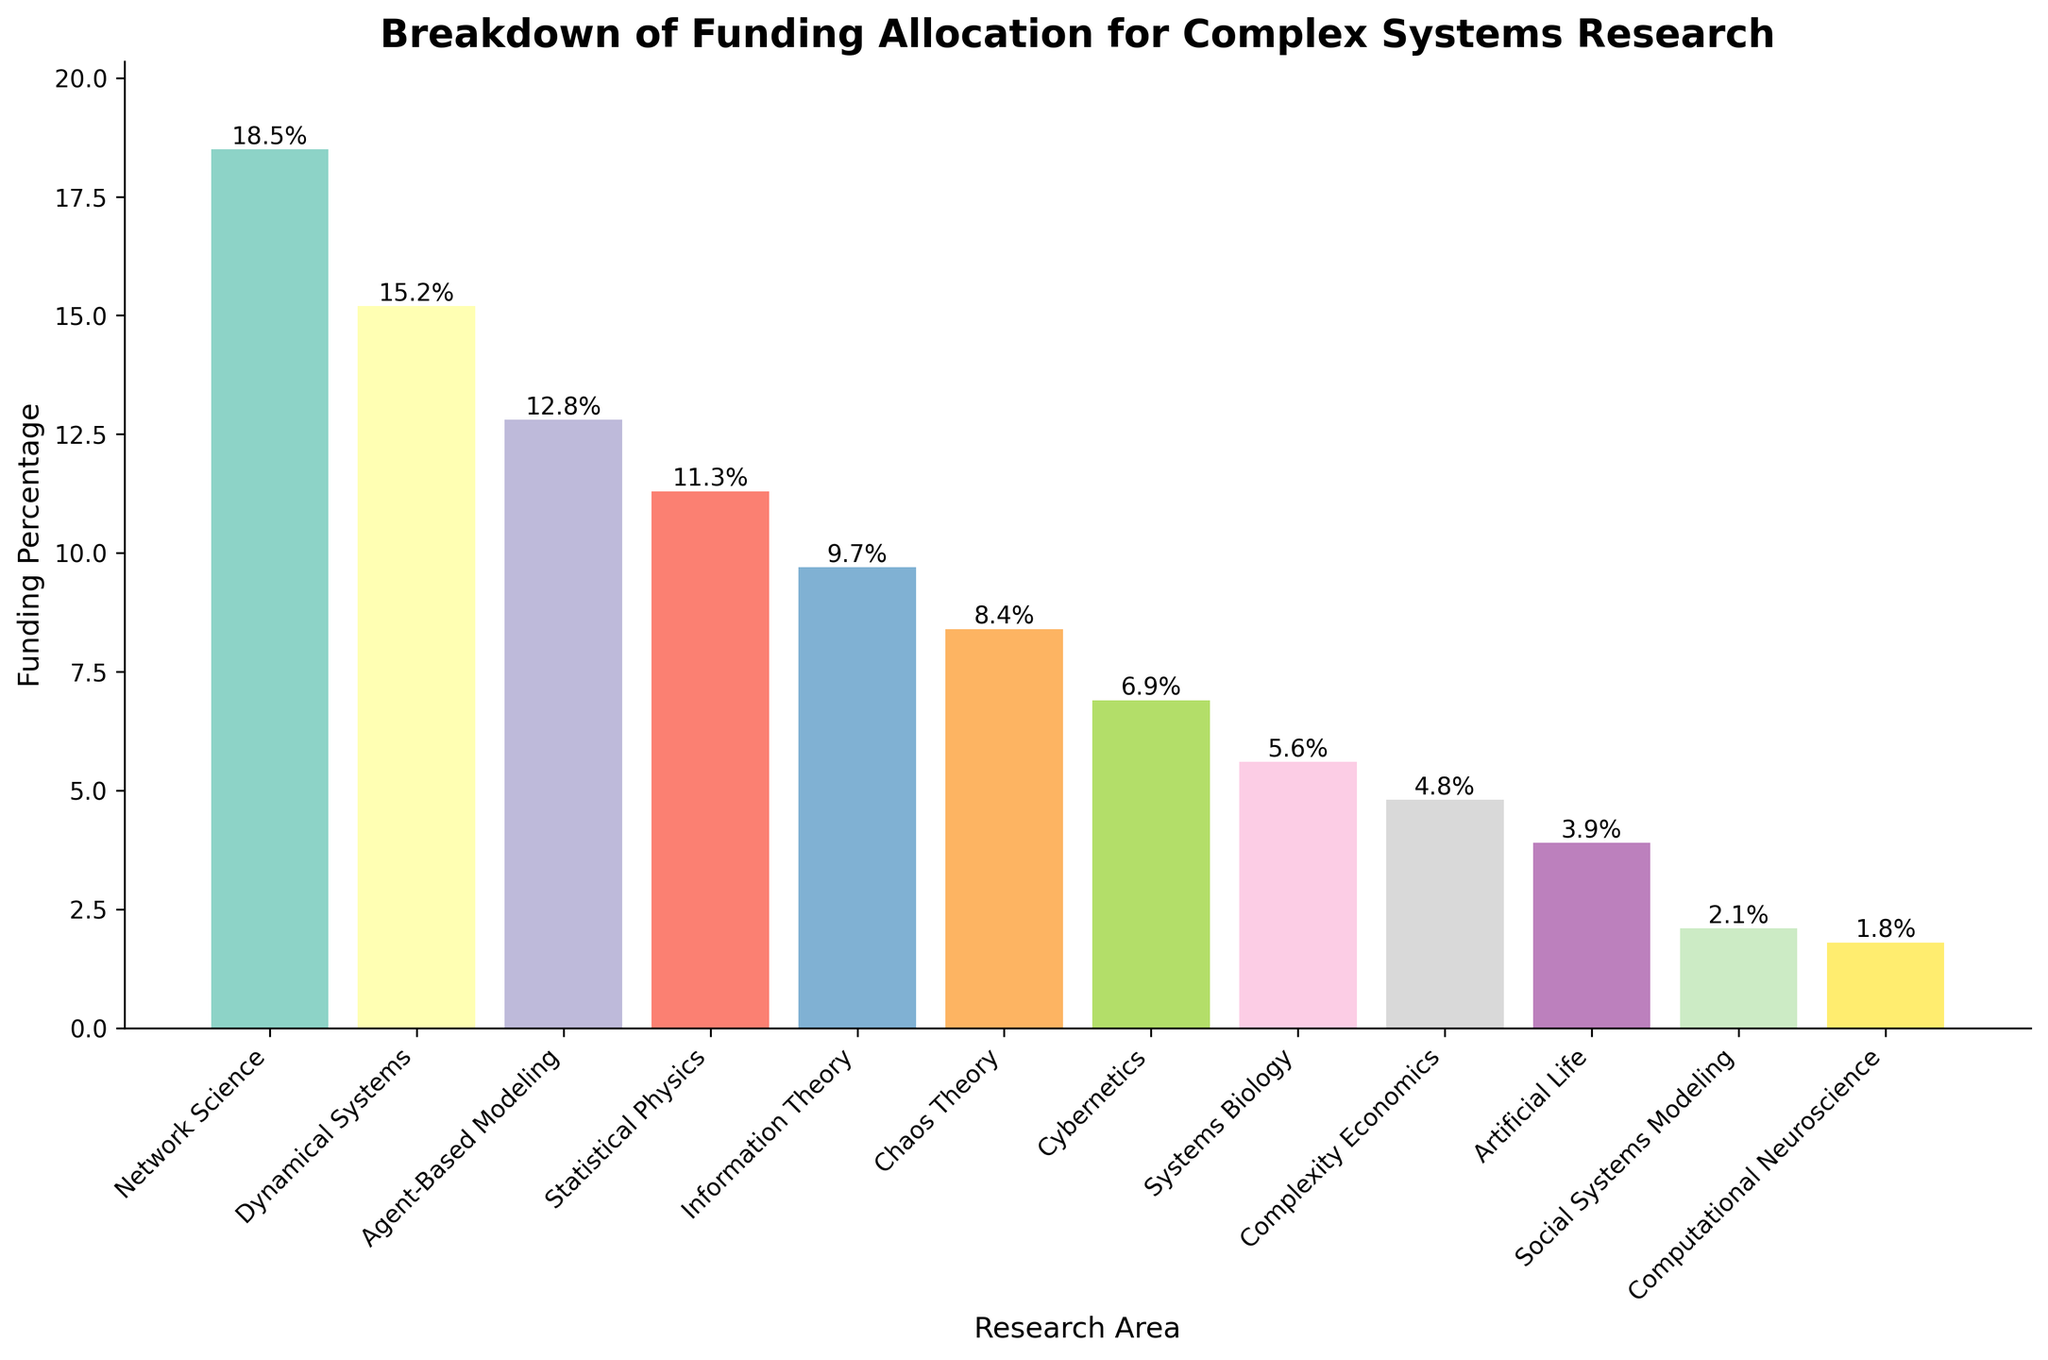What's the highest funding allocation area? The highest funding allocation area can be determined by looking for the tallest bar in the bar chart. By visual inspection, the tallest bar represents Network Science with a funding percentage of 18.5%
Answer: Network Science Which area has a lower funding percentage, Cybernetics or Systems Biology? To determine which area has a lower funding percentage, compare the heights of the bars representing Cybernetics and Systems Biology. Cybernetics has a funding percentage of 6.9%, while Systems Biology has a funding percentage of 5.6%, making it lower.
Answer: Systems Biology What is the combined funding percentage for Artificial Life and Social Systems Modeling? The combined funding percentage is found by adding the percentages of Artificial Life and Social Systems Modeling. Artificial Life has 3.9% and Social Systems Modeling has 2.1%. Therefore, the combined funding percentage is 3.9% + 2.1% = 6%.
Answer: 6% By how much does the funding for Network Science exceed that of Statistical Physics? To find the difference, subtract the percentage of Statistical Physics from that of Network Science. Network Science is at 18.5%, while Statistical Physics is at 11.3%. The difference is 18.5% - 11.3% = 7.2%.
Answer: 7.2% Which area has the second-lowest funding allocation? The second-lowest funding allocation can be identified by looking for the second shortest bar in the chart. Computational Neuroscience has the lowest funding at 1.8%, and Social Systems Modeling has the second-lowest at 2.1%.
Answer: Social Systems Modeling What is the average funding percentage across all the listed research areas? The average funding percentage is calculated by summing all the provided percentages and dividing by the number of areas. Sum: 18.5 + 15.2 + 12.8 + 11.3 + 9.7 + 8.4 + 6.9 + 5.6 + 4.8 + 3.9 + 2.1 + 1.8 = 100, and there are 12 areas. Therefore, the average is 100 / 12 ≈ 8.33%.
Answer: 8.33% Which two areas have funding percentages that add up to approximately 20%? Look at the bar chart to find two areas where their funding percentages sum close to 20%. Dynamical Systems (15.2%) and Artificial Life (3.9%) together sum to 19.1%.
Answer: Dynamical Systems and Artificial Life Which area represents about half of the funding allocated to Network Science? Network Science has a funding percentage of 18.5%. Half of this is 18.5% / 2 = 9.25%. Look for an area with a funding percentage close to 9.25%. Information Theory, at 9.7%, is the closest.
Answer: Information Theory 